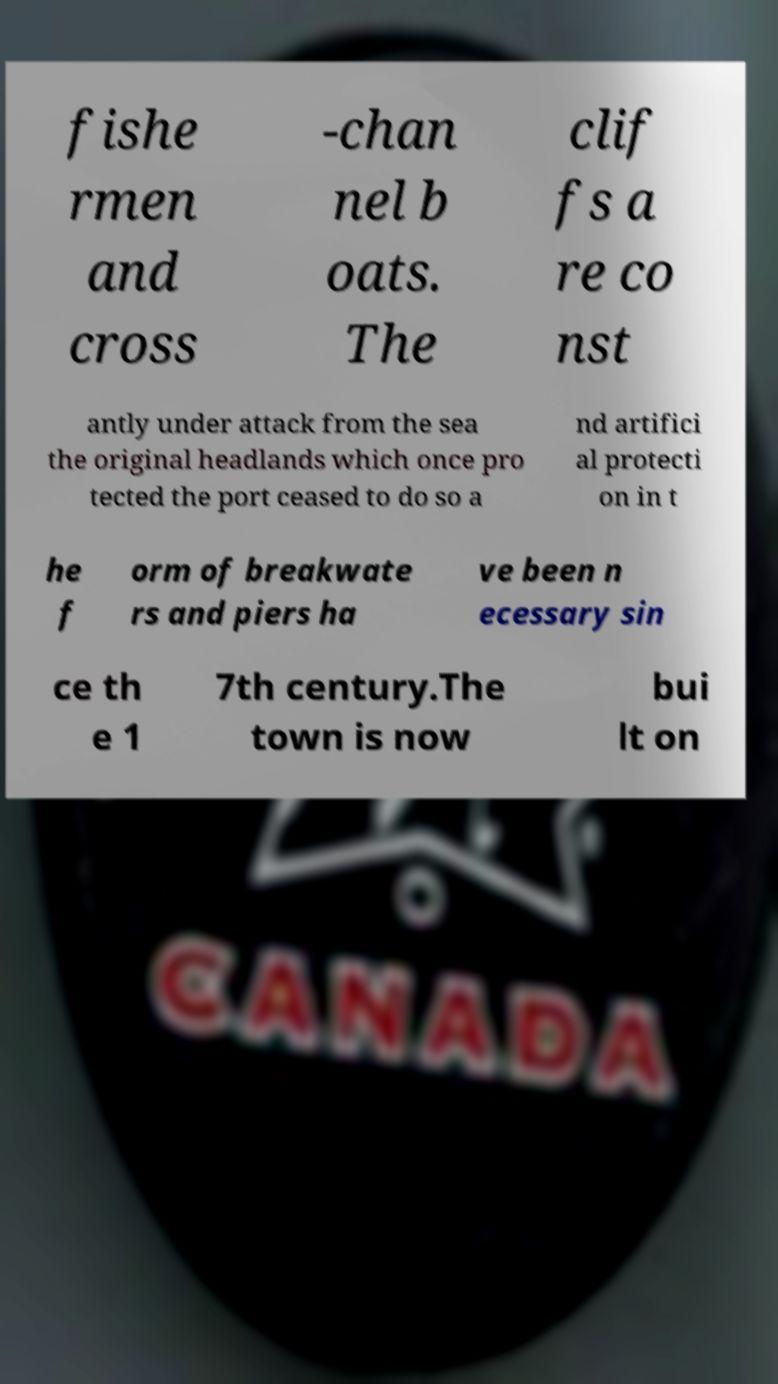Please read and relay the text visible in this image. What does it say? fishe rmen and cross -chan nel b oats. The clif fs a re co nst antly under attack from the sea the original headlands which once pro tected the port ceased to do so a nd artifici al protecti on in t he f orm of breakwate rs and piers ha ve been n ecessary sin ce th e 1 7th century.The town is now bui lt on 